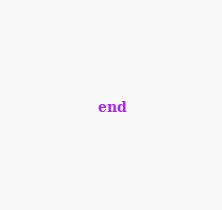Convert code to text. <code><loc_0><loc_0><loc_500><loc_500><_Ruby_>end
</code> 